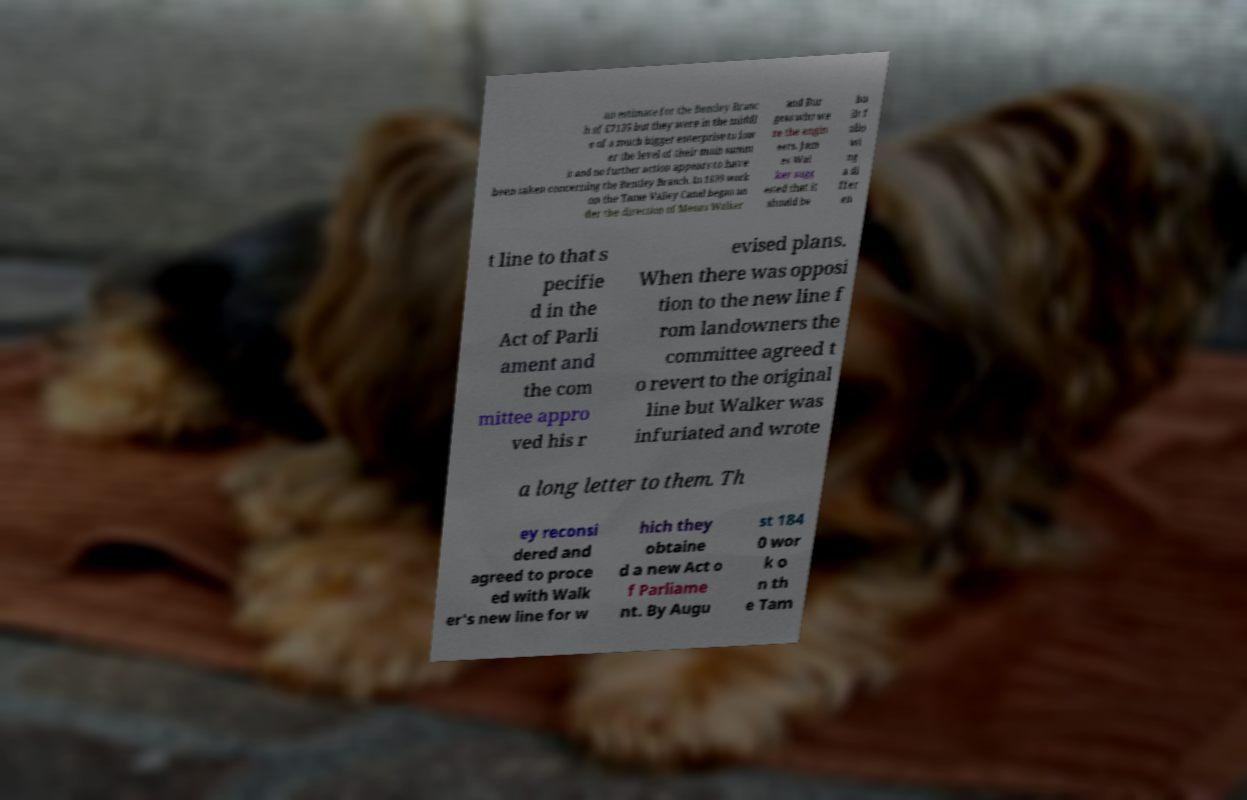I need the written content from this picture converted into text. Can you do that? an estimate for the Bentley Branc h of £7135 but they were in the middl e of a much bigger enterprise to low er the level of their main summ it and no further action appears to have been taken concerning the Bentley Branch. In 1839 work on the Tame Valley Canal began un der the direction of Messrs Walker and Bur gess who we re the engin eers. Jam es Wal ker sugg ested that it should be bu ilt f ollo wi ng a di ffer en t line to that s pecifie d in the Act of Parli ament and the com mittee appro ved his r evised plans. When there was opposi tion to the new line f rom landowners the committee agreed t o revert to the original line but Walker was infuriated and wrote a long letter to them. Th ey reconsi dered and agreed to proce ed with Walk er's new line for w hich they obtaine d a new Act o f Parliame nt. By Augu st 184 0 wor k o n th e Tam 